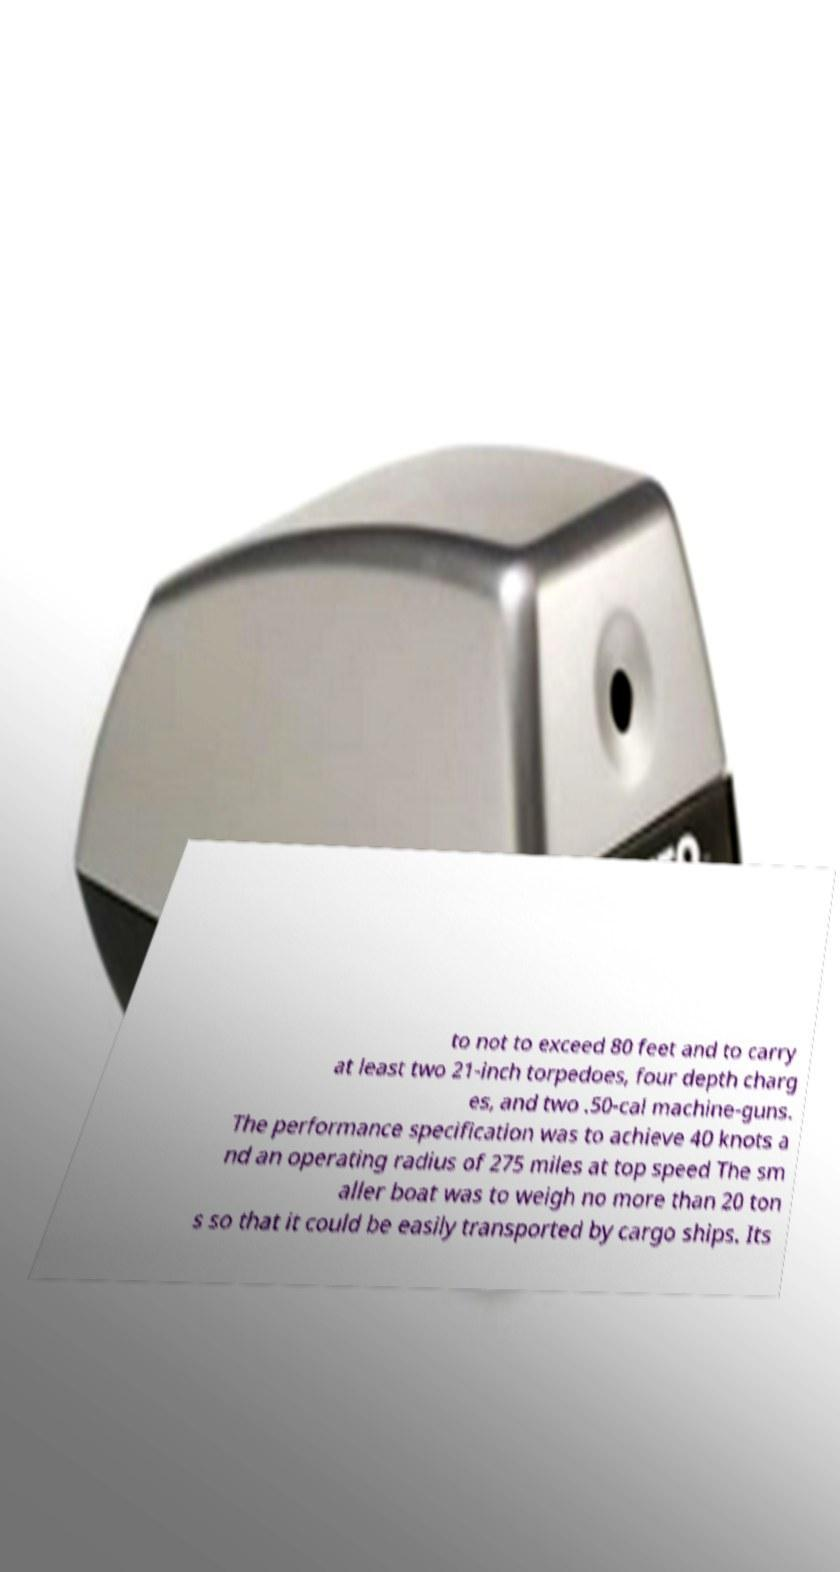Could you extract and type out the text from this image? to not to exceed 80 feet and to carry at least two 21-inch torpedoes, four depth charg es, and two .50-cal machine-guns. The performance specification was to achieve 40 knots a nd an operating radius of 275 miles at top speed The sm aller boat was to weigh no more than 20 ton s so that it could be easily transported by cargo ships. Its 